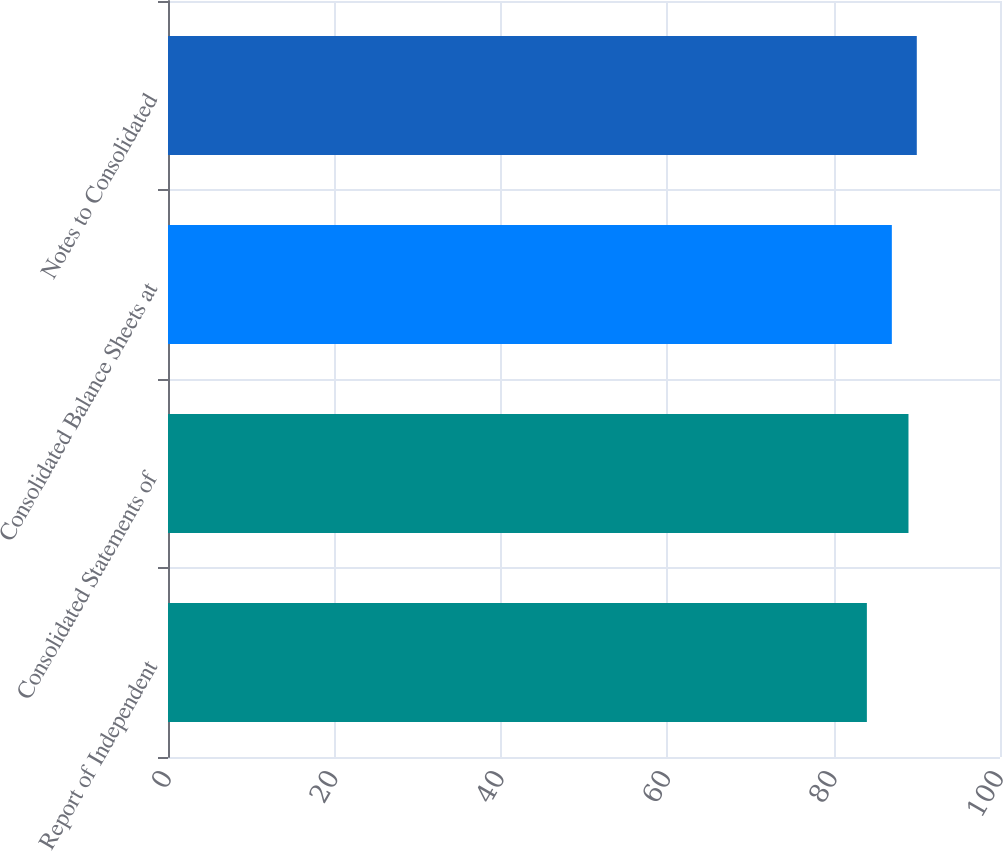Convert chart. <chart><loc_0><loc_0><loc_500><loc_500><bar_chart><fcel>Report of Independent<fcel>Consolidated Statements of<fcel>Consolidated Balance Sheets at<fcel>Notes to Consolidated<nl><fcel>84<fcel>89<fcel>87<fcel>90<nl></chart> 